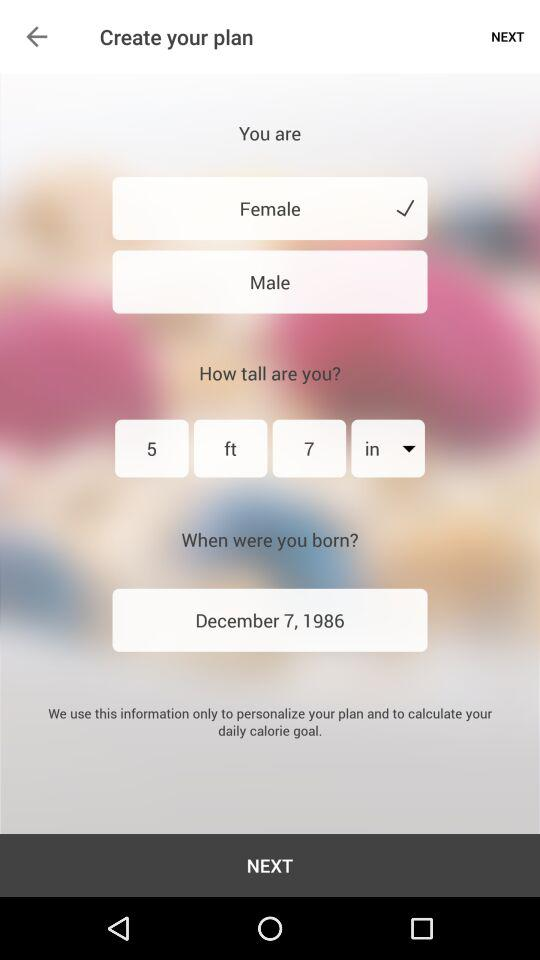What is the date of birth? The date of birth is December 7, 1986. 